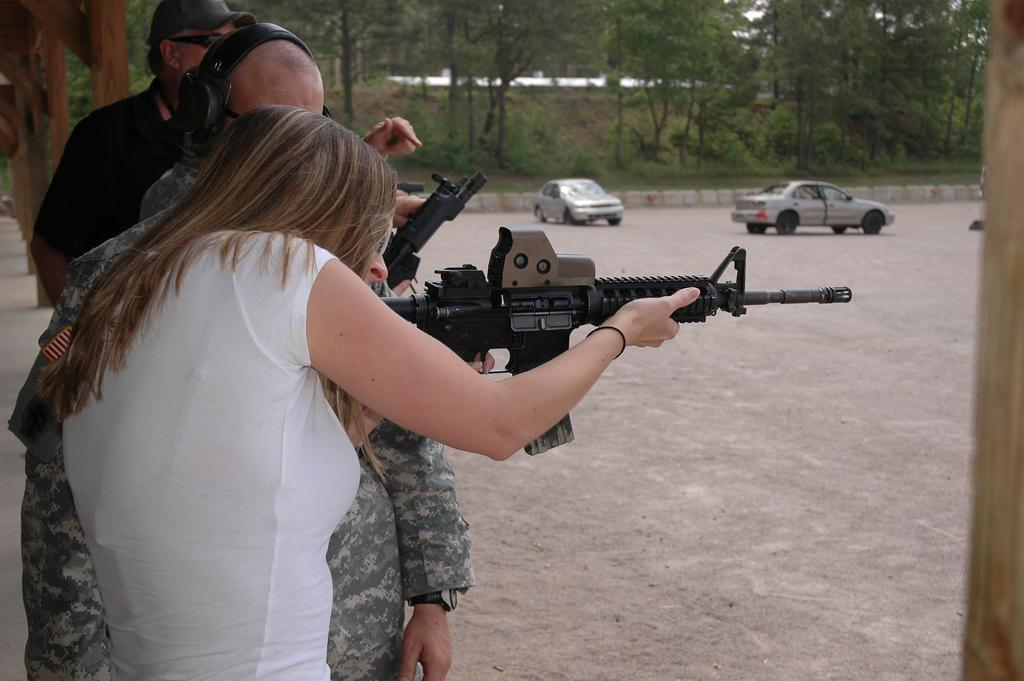Who is the main subject in the image? There is a woman in the image. What is the woman holding in the image? The woman is holding a gun. Can you describe the people visible behind the woman? There are people visible behind the woman, but their specific actions or expressions cannot be determined from the image. What can be seen in the background of the image? In the background of the image, there are vehicles, trees, plants, and wooden objects. What direction is the woman facing in relation to the pump in the image? There is no pump present in the image, so it is not possible to determine the direction the woman is facing in relation to it. 